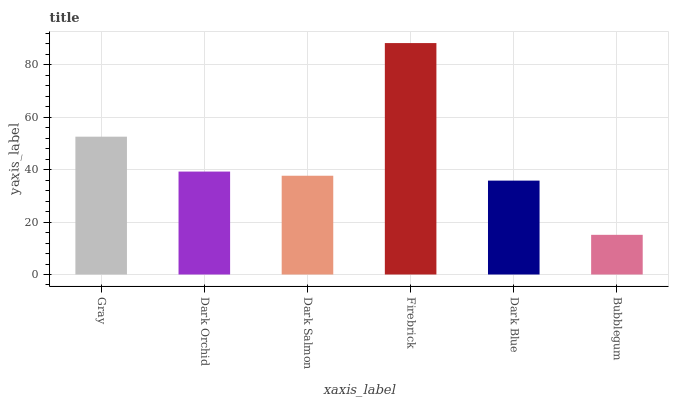Is Dark Orchid the minimum?
Answer yes or no. No. Is Dark Orchid the maximum?
Answer yes or no. No. Is Gray greater than Dark Orchid?
Answer yes or no. Yes. Is Dark Orchid less than Gray?
Answer yes or no. Yes. Is Dark Orchid greater than Gray?
Answer yes or no. No. Is Gray less than Dark Orchid?
Answer yes or no. No. Is Dark Orchid the high median?
Answer yes or no. Yes. Is Dark Salmon the low median?
Answer yes or no. Yes. Is Dark Blue the high median?
Answer yes or no. No. Is Gray the low median?
Answer yes or no. No. 